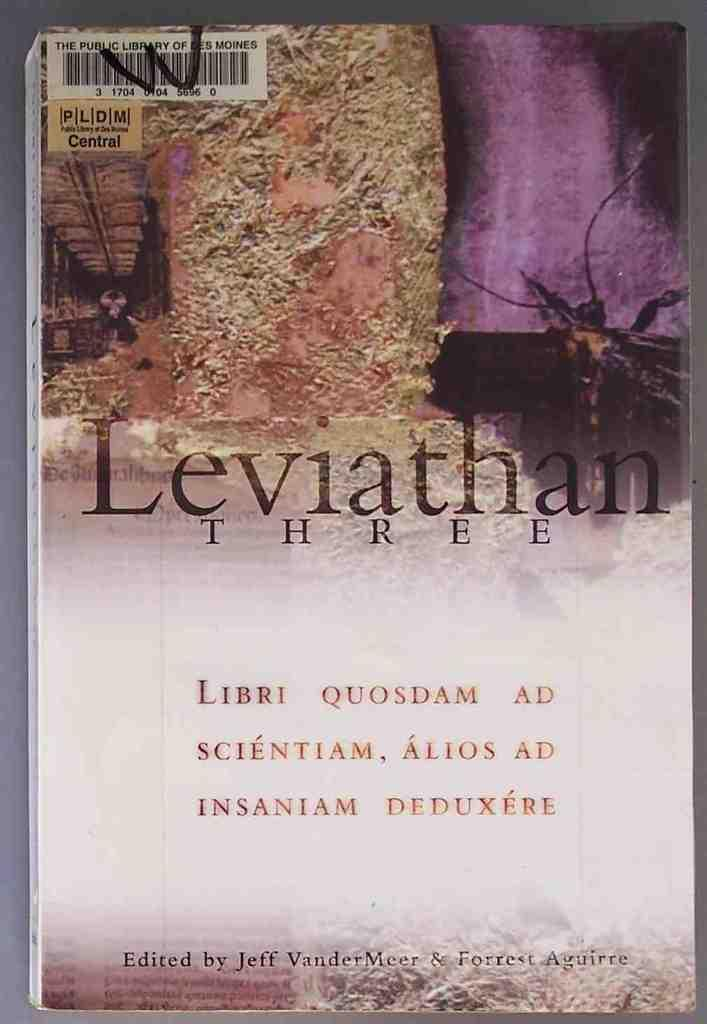<image>
Present a compact description of the photo's key features. A book by the title of Leviathan three 